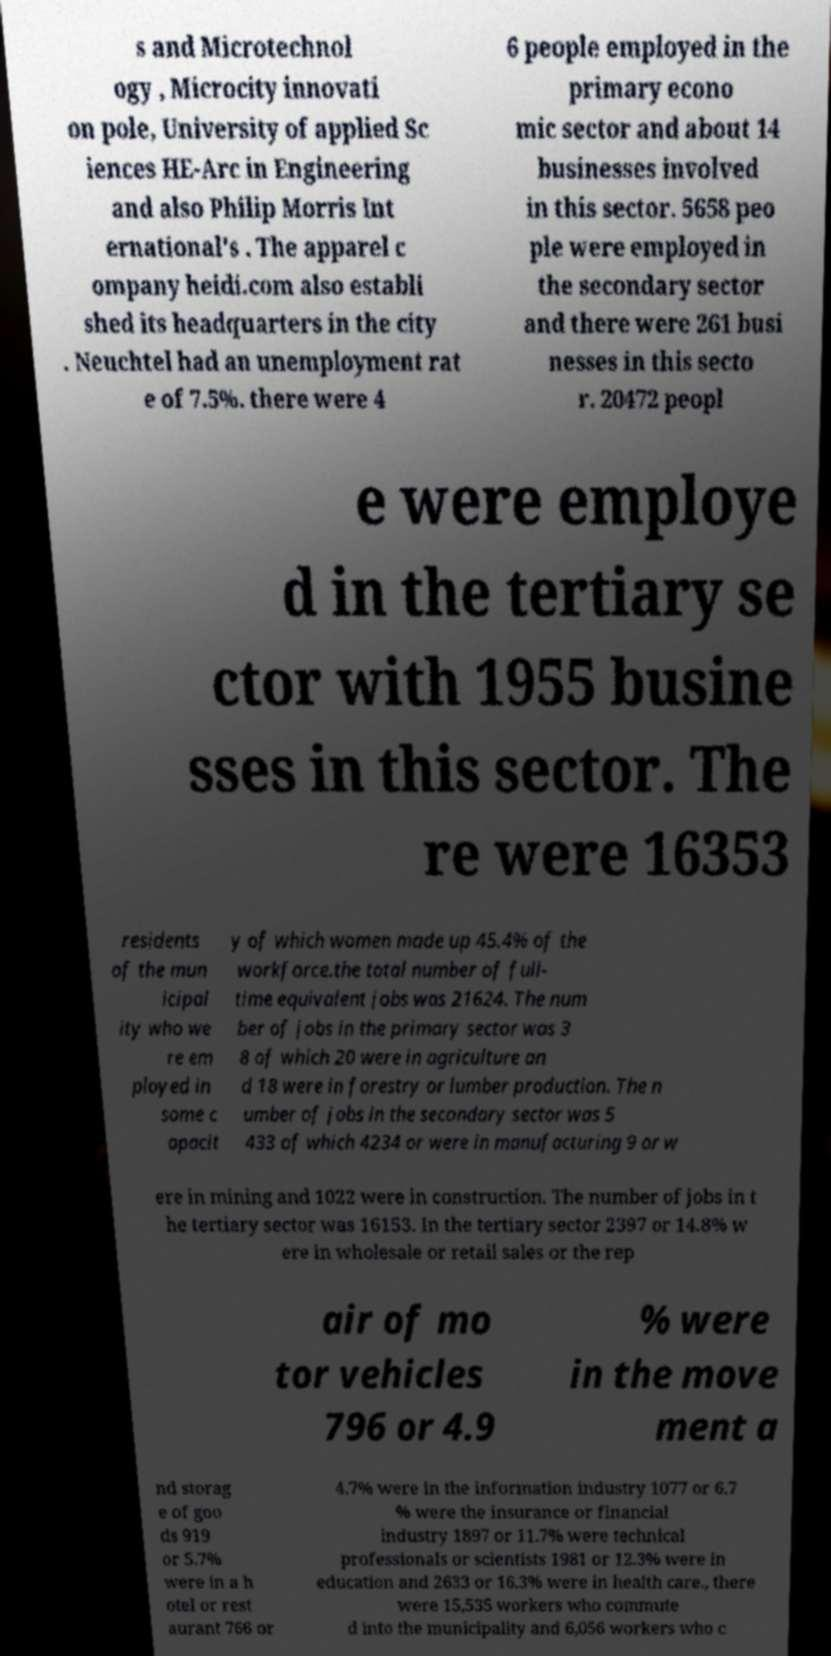Please identify and transcribe the text found in this image. s and Microtechnol ogy , Microcity innovati on pole, University of applied Sc iences HE-Arc in Engineering and also Philip Morris Int ernational's . The apparel c ompany heidi.com also establi shed its headquarters in the city . Neuchtel had an unemployment rat e of 7.5%. there were 4 6 people employed in the primary econo mic sector and about 14 businesses involved in this sector. 5658 peo ple were employed in the secondary sector and there were 261 busi nesses in this secto r. 20472 peopl e were employe d in the tertiary se ctor with 1955 busine sses in this sector. The re were 16353 residents of the mun icipal ity who we re em ployed in some c apacit y of which women made up 45.4% of the workforce.the total number of full- time equivalent jobs was 21624. The num ber of jobs in the primary sector was 3 8 of which 20 were in agriculture an d 18 were in forestry or lumber production. The n umber of jobs in the secondary sector was 5 433 of which 4234 or were in manufacturing 9 or w ere in mining and 1022 were in construction. The number of jobs in t he tertiary sector was 16153. In the tertiary sector 2397 or 14.8% w ere in wholesale or retail sales or the rep air of mo tor vehicles 796 or 4.9 % were in the move ment a nd storag e of goo ds 919 or 5.7% were in a h otel or rest aurant 766 or 4.7% were in the information industry 1077 or 6.7 % were the insurance or financial industry 1897 or 11.7% were technical professionals or scientists 1981 or 12.3% were in education and 2633 or 16.3% were in health care., there were 15,535 workers who commute d into the municipality and 6,056 workers who c 